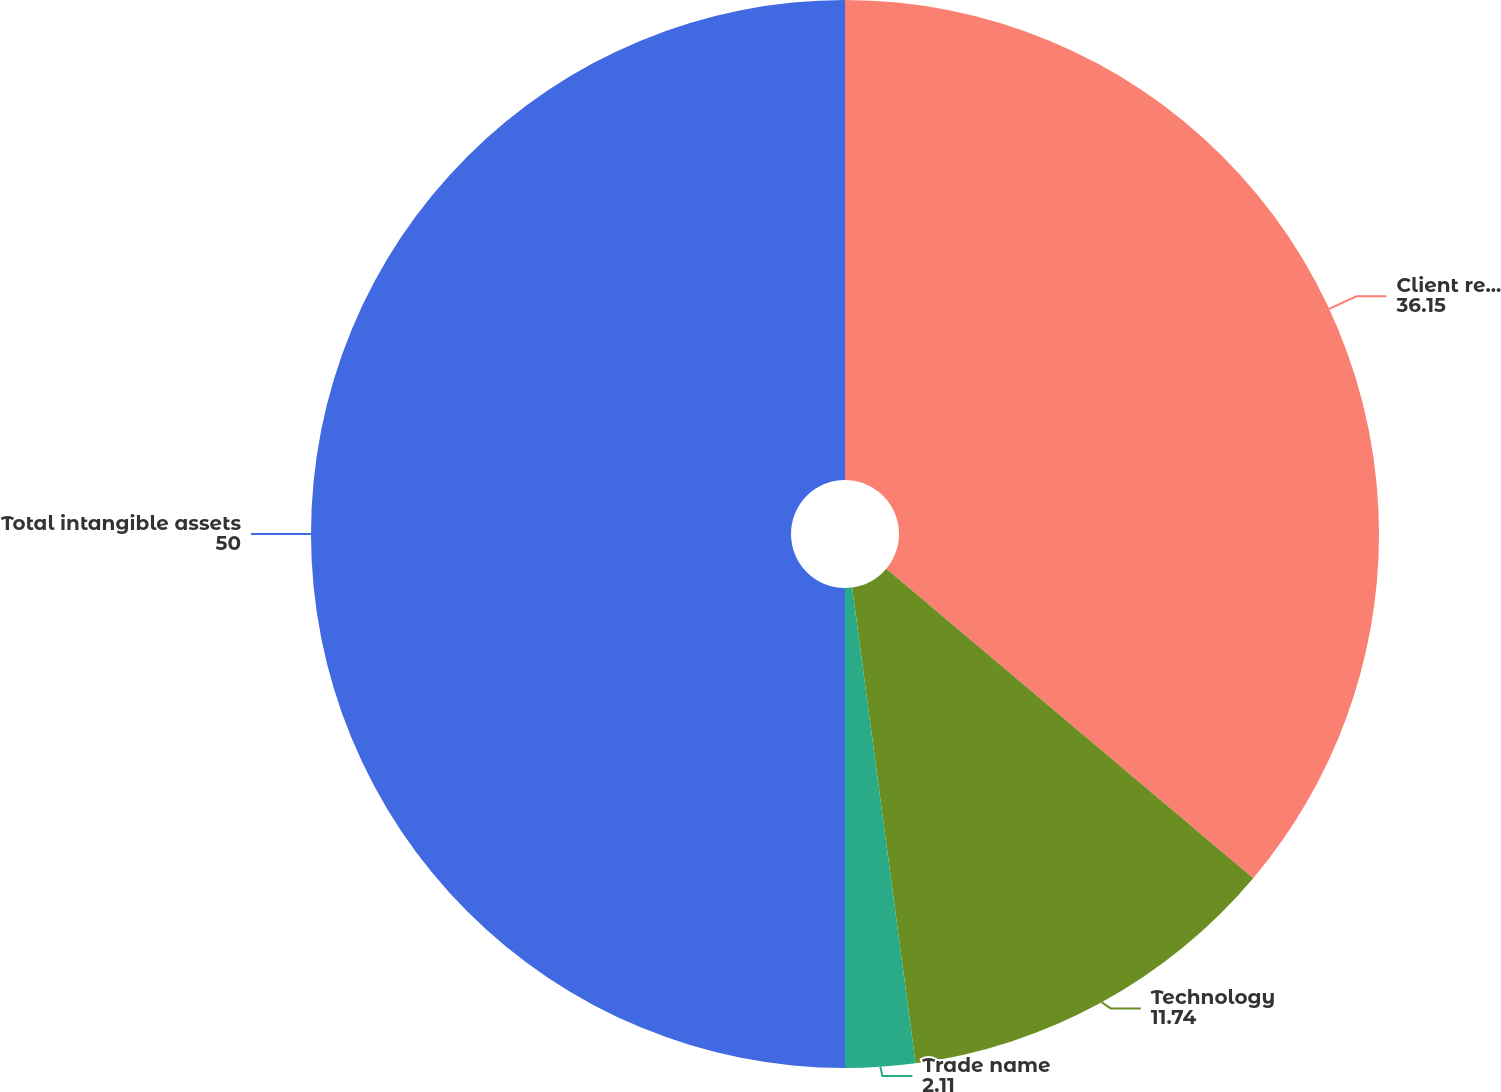<chart> <loc_0><loc_0><loc_500><loc_500><pie_chart><fcel>Client relationships<fcel>Technology<fcel>Trade name<fcel>Total intangible assets<nl><fcel>36.15%<fcel>11.74%<fcel>2.11%<fcel>50.0%<nl></chart> 